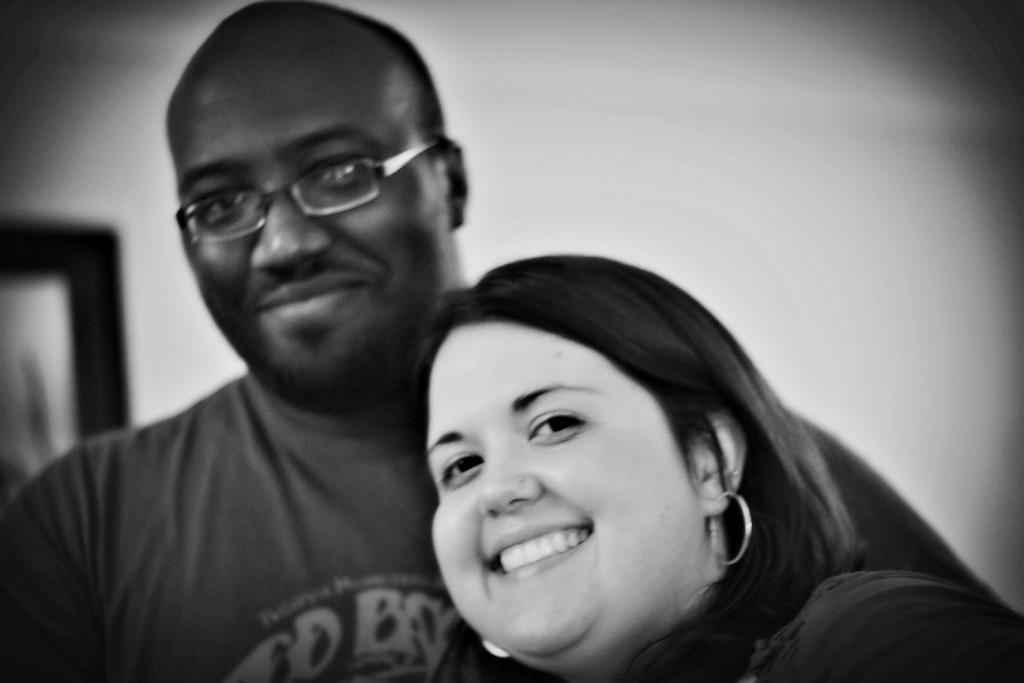How many people are present in the image? There are two people in the image, a man and a woman. What are the expressions on their faces? Both the man and the woman are smiling in the image. Can you describe any specific feature of the man? The man is wearing spectacles in the image. What type of arch can be seen in the background of the image? There is no arch present in the background of the image. What kind of apparel is the woman wearing in the image? The provided facts do not mention any specific apparel worn by the woman in the image. 